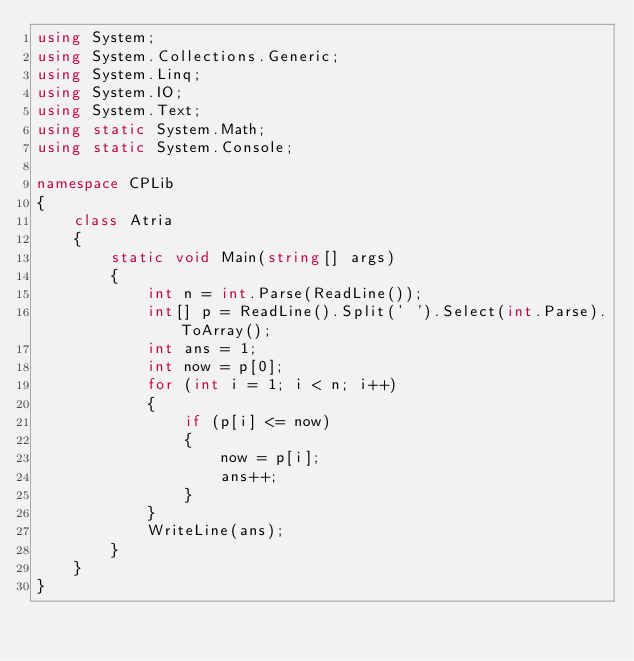Convert code to text. <code><loc_0><loc_0><loc_500><loc_500><_C#_>using System;
using System.Collections.Generic;
using System.Linq;
using System.IO;
using System.Text;
using static System.Math;
using static System.Console;

namespace CPLib
{
    class Atria
    {
        static void Main(string[] args)
        {
            int n = int.Parse(ReadLine());
            int[] p = ReadLine().Split(' ').Select(int.Parse).ToArray();
            int ans = 1;
            int now = p[0];
            for (int i = 1; i < n; i++)
            {
                if (p[i] <= now)
                {
                    now = p[i];
                    ans++;
                }
            }
            WriteLine(ans);
        }
    }
}
</code> 